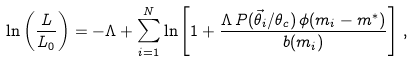<formula> <loc_0><loc_0><loc_500><loc_500>\ln \left ( \frac { L } { L _ { 0 } } \right ) = - \Lambda + \sum _ { i = 1 } ^ { N } \ln \left [ 1 + \frac { \Lambda \, P ( \vec { \theta } _ { i } / \theta _ { c } ) \, \phi ( m _ { i } - m ^ { * } ) } { b ( m _ { i } ) } \right ] \, ,</formula> 